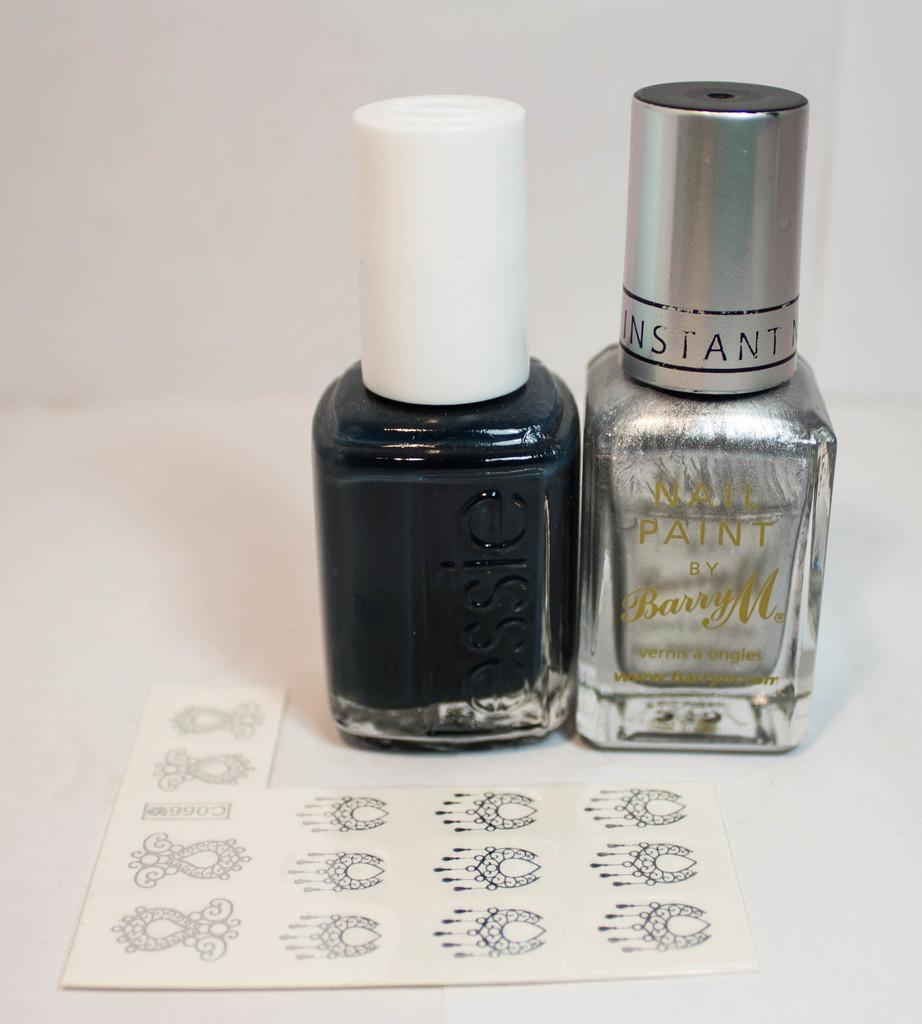<image>
Give a short and clear explanation of the subsequent image. Two bottles of nail polish, one black and one silver, with the logo instant on the silver one. 